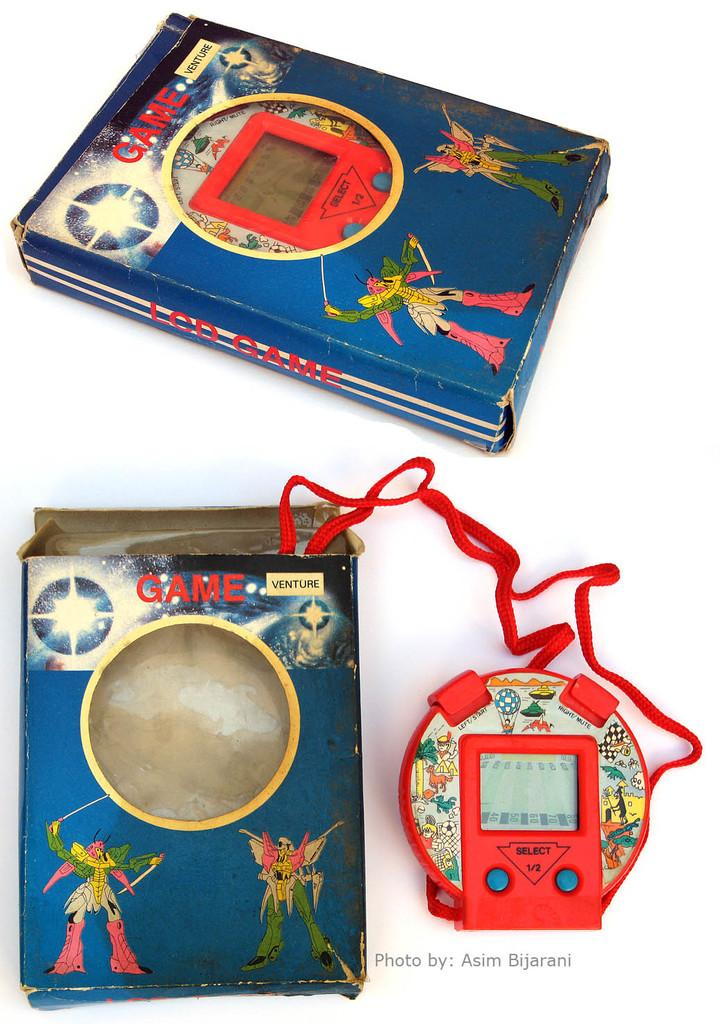How many blue boxes are visible in the image? There are two blue boxes in the image. What other item can be seen in the image besides the blue boxes? There is a gaming console in the image. What colors are present on the gaming console? The gaming console is red and blue in color. What is the color of the background in the image? The background of the image is white. How many men are visible in the picture on the page in the image? There are no men, pictures, or pages present in the image; it only contains two blue boxes and a gaming console. 